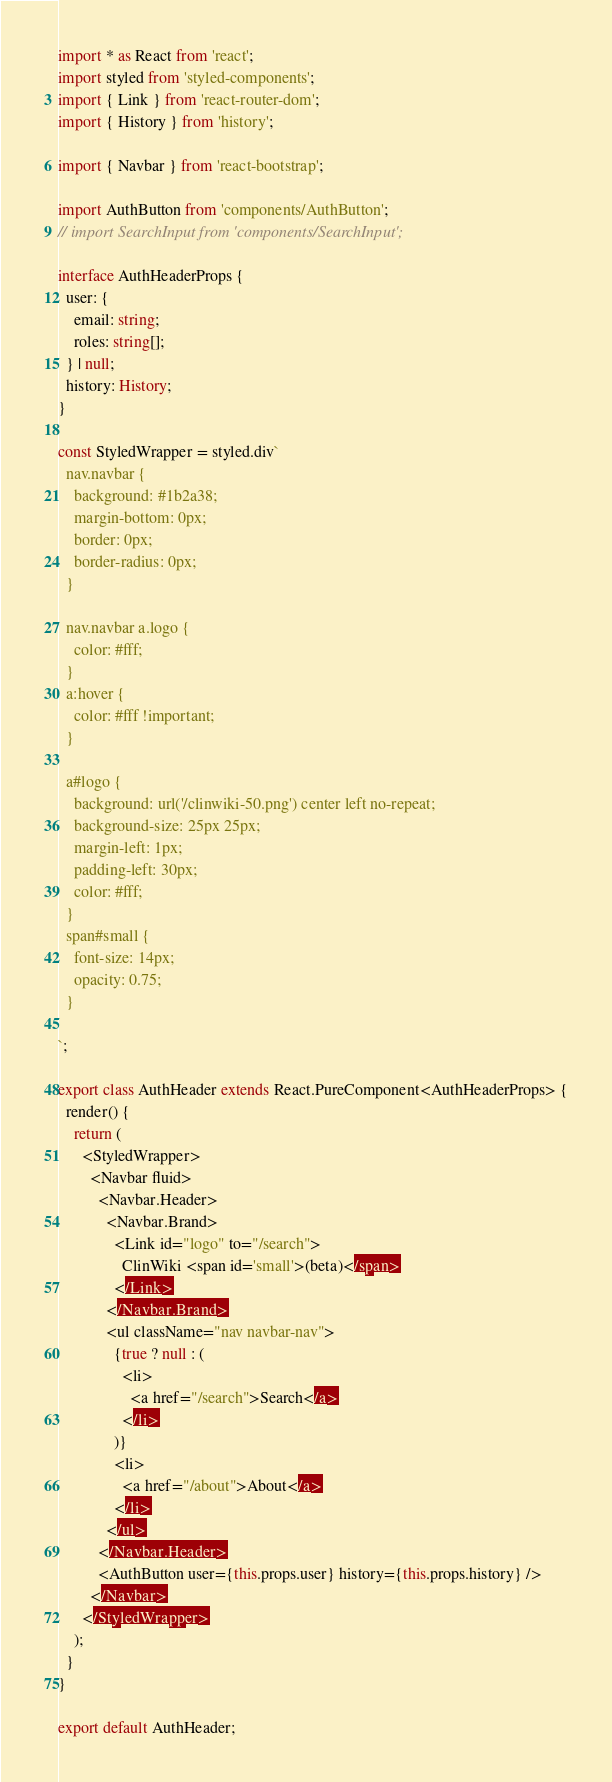Convert code to text. <code><loc_0><loc_0><loc_500><loc_500><_TypeScript_>import * as React from 'react';
import styled from 'styled-components';
import { Link } from 'react-router-dom';
import { History } from 'history';

import { Navbar } from 'react-bootstrap';

import AuthButton from 'components/AuthButton';
// import SearchInput from 'components/SearchInput';

interface AuthHeaderProps {
  user: {
    email: string;
    roles: string[];
  } | null;
  history: History;
}

const StyledWrapper = styled.div`
  nav.navbar {
    background: #1b2a38;
    margin-bottom: 0px;
    border: 0px;
    border-radius: 0px;
  }

  nav.navbar a.logo {
    color: #fff;
  }
  a:hover {
    color: #fff !important;
  }

  a#logo {
    background: url('/clinwiki-50.png') center left no-repeat;
    background-size: 25px 25px;
    margin-left: 1px;
    padding-left: 30px;
    color: #fff;
  }
  span#small {
    font-size: 14px;
    opacity: 0.75;
  }

`;

export class AuthHeader extends React.PureComponent<AuthHeaderProps> {
  render() {
    return (
      <StyledWrapper>
        <Navbar fluid>
          <Navbar.Header>
            <Navbar.Brand>
              <Link id="logo" to="/search">
                ClinWiki <span id='small'>(beta)</span>
              </Link>
            </Navbar.Brand>
            <ul className="nav navbar-nav">
              {true ? null : (
                <li>
                  <a href="/search">Search</a>
                </li>
              )}
              <li>
                <a href="/about">About</a>
              </li>
            </ul>
          </Navbar.Header>
          <AuthButton user={this.props.user} history={this.props.history} />
        </Navbar>
      </StyledWrapper>
    );
  }
}

export default AuthHeader;
</code> 